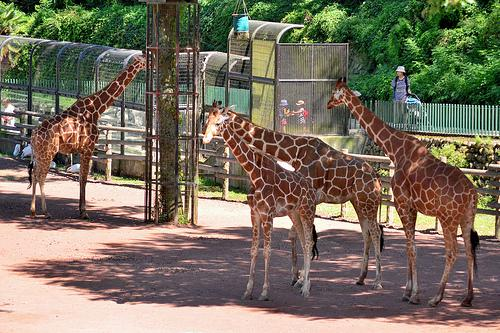Question: how many giraffes can be seen?
Choices:
A. 1.
B. 3.
C. 4.
D. 5.
Answer with the letter. Answer: C Question: where are the giraffes?
Choices:
A. In an enclosure.
B. In a park.
C. On the open plain.
D. AT zoo.
Answer with the letter. Answer: D Question: what is separating the animals from the people?
Choices:
A. A fence.
B. The wall.
C. The moat.
D. The buildings.
Answer with the letter. Answer: A Question: why are the giraffe's here?
Choices:
A. They are sick.
B. They are being rescued.
C. For people to view.
D. They were being abused.
Answer with the letter. Answer: C 